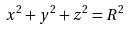Convert formula to latex. <formula><loc_0><loc_0><loc_500><loc_500>x ^ { 2 } + y ^ { 2 } + z ^ { 2 } = R ^ { 2 }</formula> 